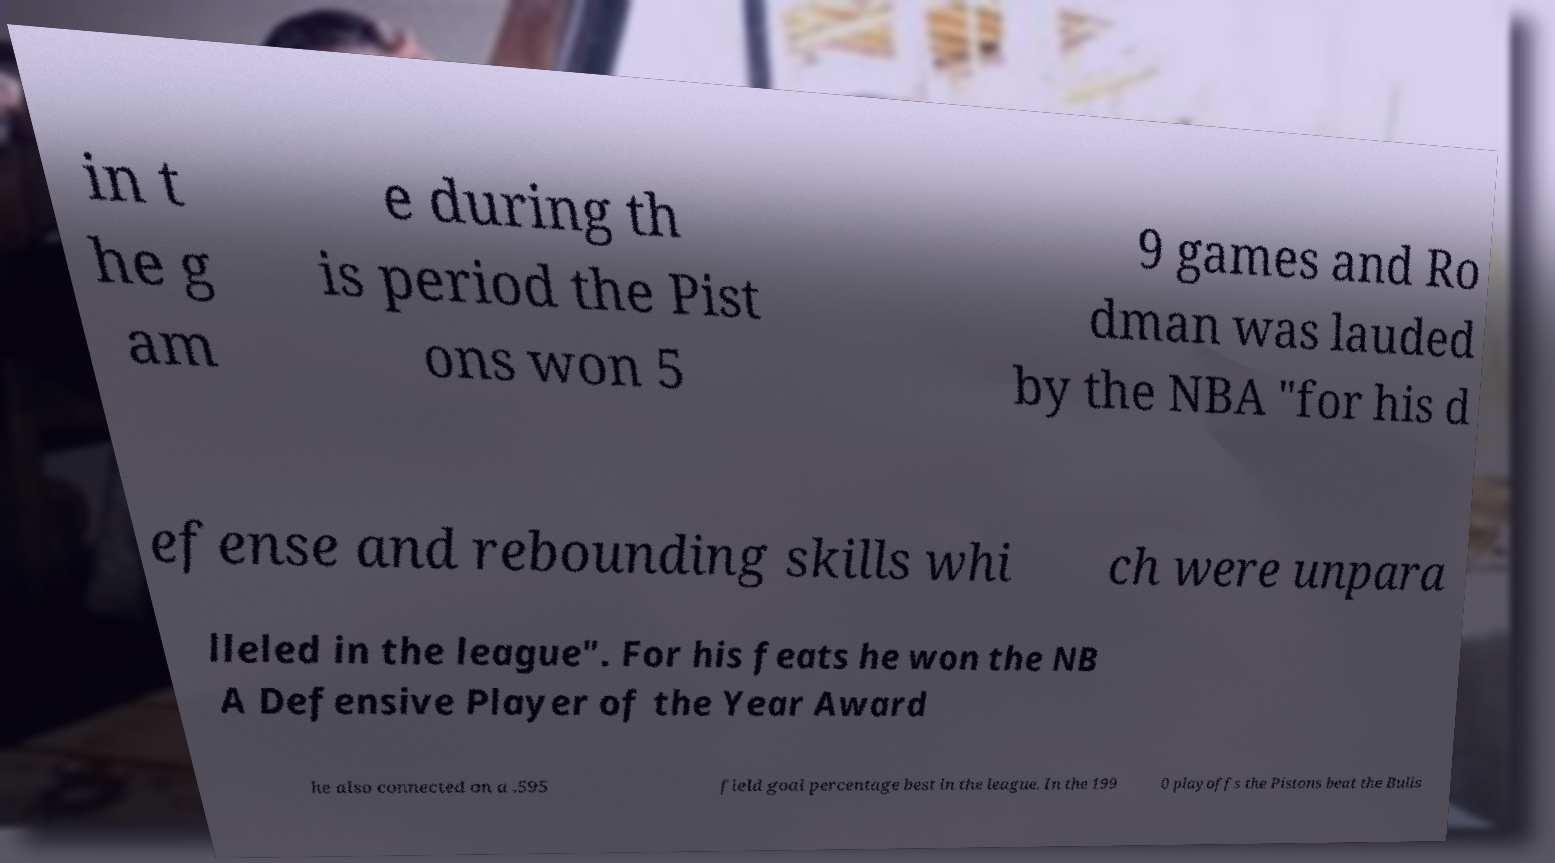Can you accurately transcribe the text from the provided image for me? in t he g am e during th is period the Pist ons won 5 9 games and Ro dman was lauded by the NBA "for his d efense and rebounding skills whi ch were unpara lleled in the league". For his feats he won the NB A Defensive Player of the Year Award he also connected on a .595 field goal percentage best in the league. In the 199 0 playoffs the Pistons beat the Bulls 